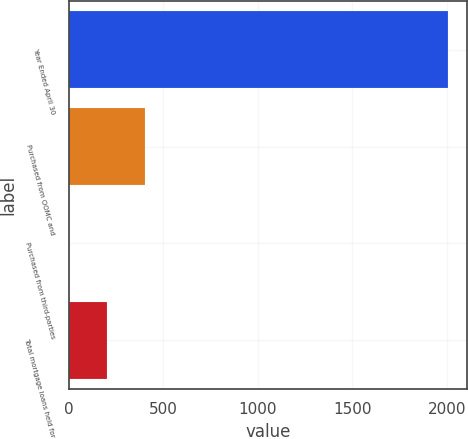Convert chart. <chart><loc_0><loc_0><loc_500><loc_500><bar_chart><fcel>Year Ended April 30<fcel>Purchased from OOMC and<fcel>Purchased from third-parties<fcel>Total mortgage loans held for<nl><fcel>2007<fcel>401.8<fcel>0.5<fcel>201.15<nl></chart> 